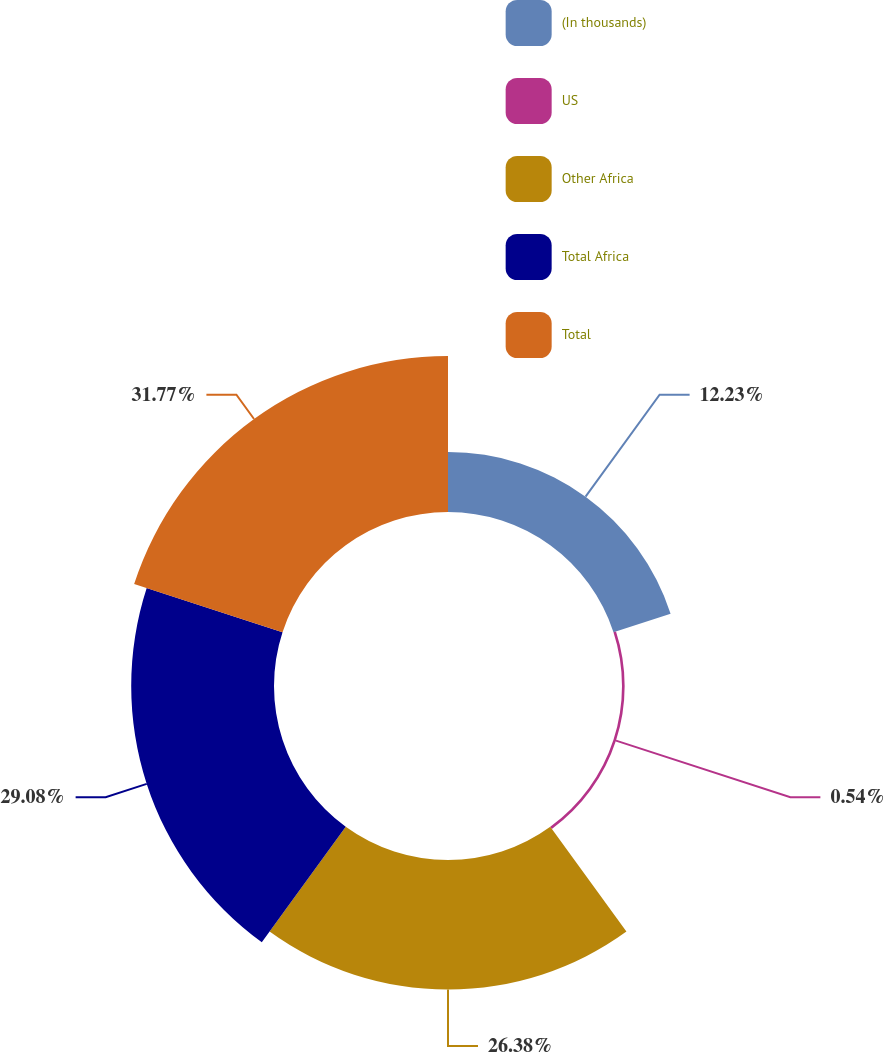Convert chart. <chart><loc_0><loc_0><loc_500><loc_500><pie_chart><fcel>(In thousands)<fcel>US<fcel>Other Africa<fcel>Total Africa<fcel>Total<nl><fcel>12.23%<fcel>0.54%<fcel>26.38%<fcel>29.08%<fcel>31.77%<nl></chart> 